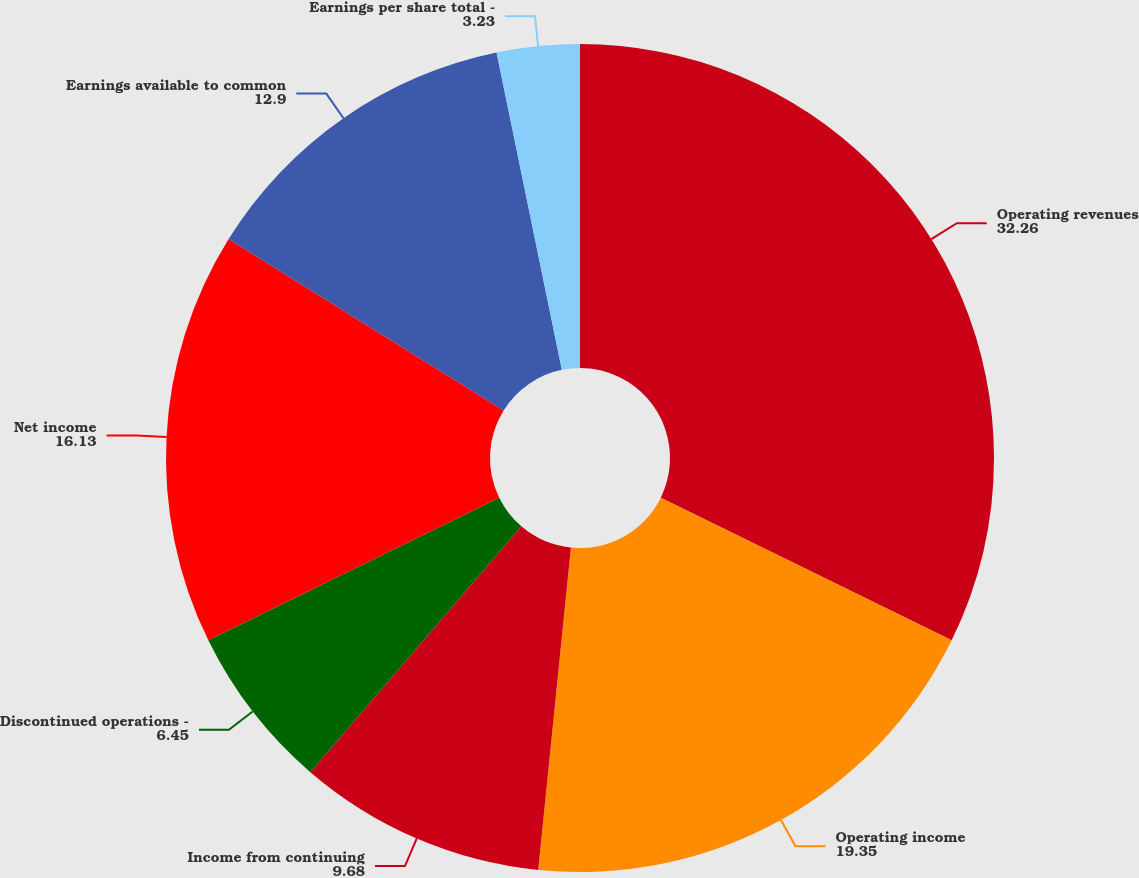Convert chart. <chart><loc_0><loc_0><loc_500><loc_500><pie_chart><fcel>Operating revenues<fcel>Operating income<fcel>Income from continuing<fcel>Discontinued operations -<fcel>Net income<fcel>Earnings available to common<fcel>Earnings per share total -<nl><fcel>32.26%<fcel>19.35%<fcel>9.68%<fcel>6.45%<fcel>16.13%<fcel>12.9%<fcel>3.23%<nl></chart> 